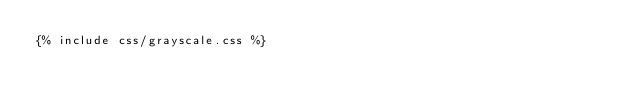Convert code to text. <code><loc_0><loc_0><loc_500><loc_500><_CSS_>{% include css/grayscale.css %}</code> 